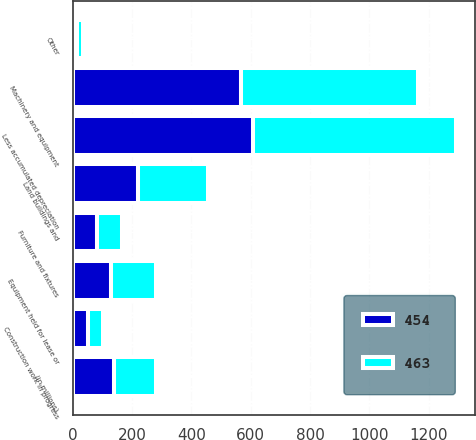Convert chart. <chart><loc_0><loc_0><loc_500><loc_500><stacked_bar_chart><ecel><fcel>(in millions)<fcel>Land buildings and<fcel>Machinery and equipment<fcel>Equipment held for lease or<fcel>Furniture and fixtures<fcel>Construction work in progress<fcel>Other<fcel>Less accumulated depreciation<nl><fcel>463<fcel>140.5<fcel>237<fcel>598<fcel>152<fcel>86<fcel>53<fcel>21<fcel>684<nl><fcel>454<fcel>140.5<fcel>220<fcel>567<fcel>129<fcel>81<fcel>51<fcel>15<fcel>609<nl></chart> 